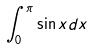Convert formula to latex. <formula><loc_0><loc_0><loc_500><loc_500>\int _ { 0 } ^ { \pi } \sin x d x</formula> 